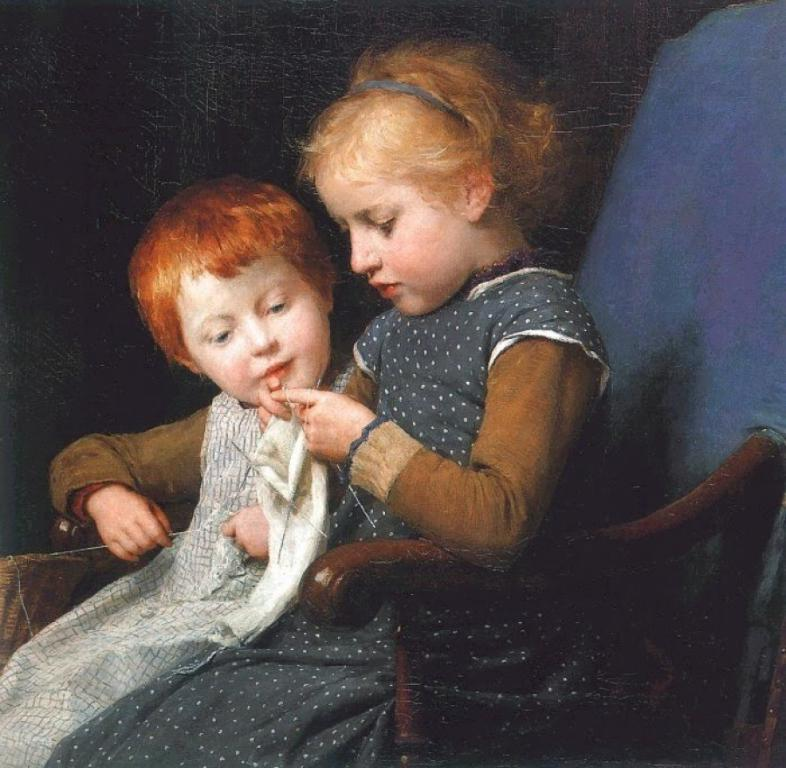How many children are in the image? There are two kids in the image. What are the kids doing in the image? The kids are sitting in a chair. What can be observed about the lighting in the image? The background of the image is dark. What date is circled on the calendar in the image? There is no calendar present in the image. What color are the crayons on the table in the image? There are no crayons present in the image. 